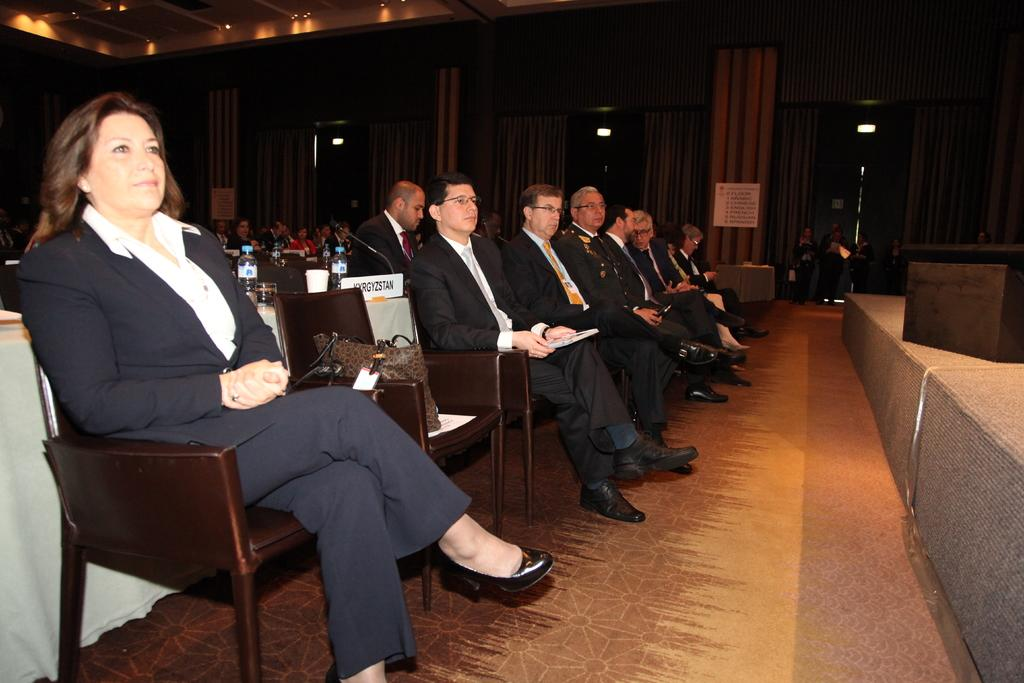How many people are in the image? There are people in the image, but the exact number is not specified. What are the people doing in the image? The people are standing on chairs in the image. What type of wire is being used to hold the pies in the image? There is no mention of pies or wire in the image, so this question cannot be answered. 